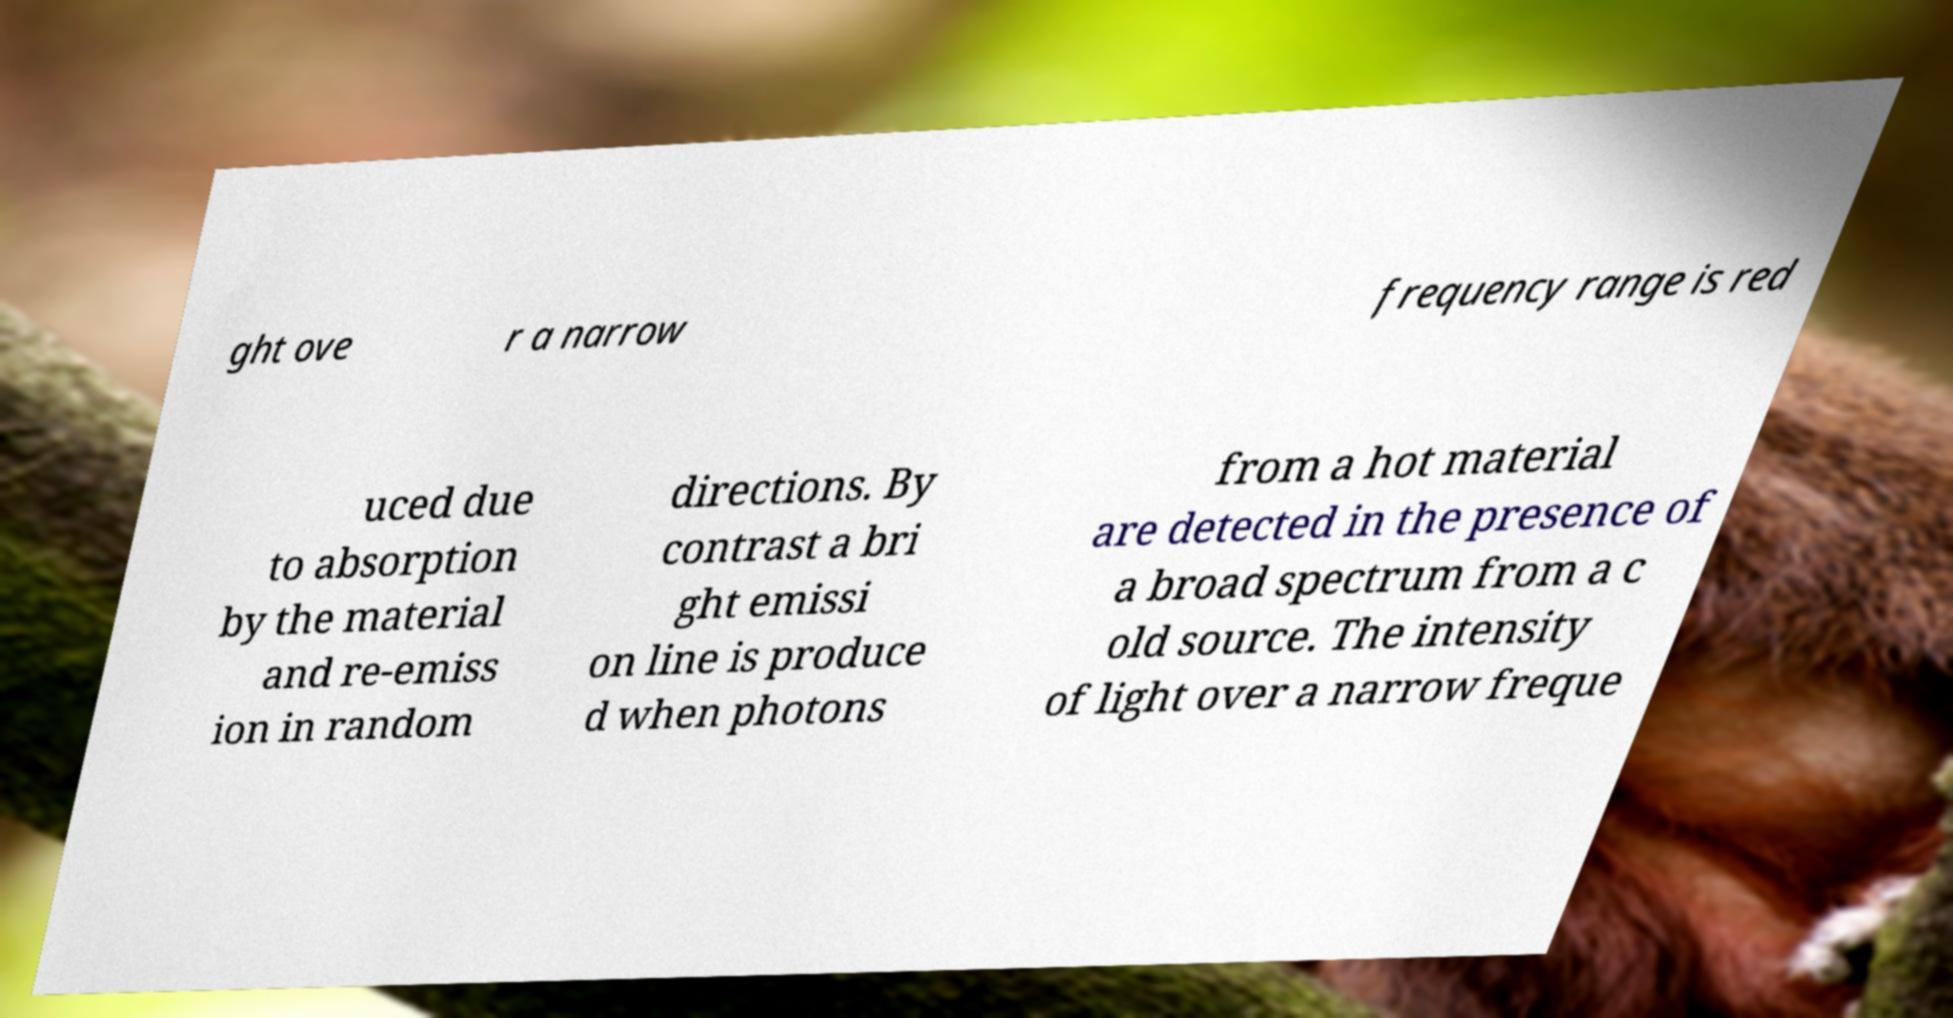Could you extract and type out the text from this image? ght ove r a narrow frequency range is red uced due to absorption by the material and re-emiss ion in random directions. By contrast a bri ght emissi on line is produce d when photons from a hot material are detected in the presence of a broad spectrum from a c old source. The intensity of light over a narrow freque 